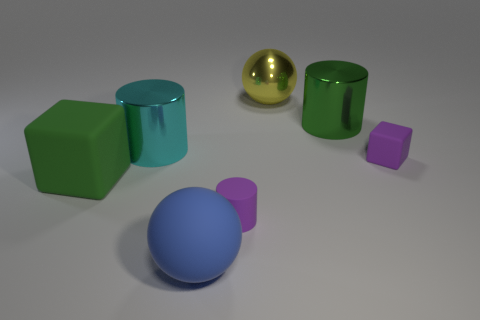How many things are either purple rubber things that are behind the large green matte object or cylinders?
Provide a succinct answer. 4. There is a matte cylinder that is the same size as the purple block; what is its color?
Provide a succinct answer. Purple. Are there more large cyan cylinders left of the big blue rubber object than big green things?
Offer a very short reply. No. What is the material of the cylinder that is both behind the small rubber cylinder and on the right side of the large matte sphere?
Your answer should be very brief. Metal. Does the tiny object in front of the large green block have the same color as the large ball in front of the purple matte cylinder?
Offer a terse response. No. How many other things are there of the same size as the blue object?
Your answer should be compact. 4. There is a big metallic thing that is in front of the big cylinder that is on the right side of the large cyan thing; is there a large sphere that is in front of it?
Provide a succinct answer. Yes. Are the green thing in front of the large green shiny cylinder and the purple cylinder made of the same material?
Offer a terse response. Yes. The other thing that is the same shape as the large blue object is what color?
Your answer should be very brief. Yellow. Is there anything else that has the same shape as the blue matte thing?
Provide a short and direct response. Yes. 